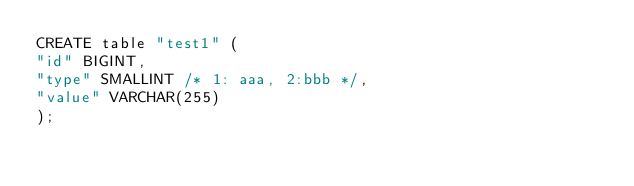Convert code to text. <code><loc_0><loc_0><loc_500><loc_500><_SQL_>CREATE table "test1" (
"id" BIGINT,
"type" SMALLINT /* 1: aaa, 2:bbb */,
"value" VARCHAR(255)
);</code> 